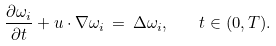Convert formula to latex. <formula><loc_0><loc_0><loc_500><loc_500>\frac { \partial \omega _ { i } } { \partial t } + u \cdot \nabla \omega _ { i } \, = \, \Delta \omega _ { i } , \quad t \in ( 0 , T ) .</formula> 